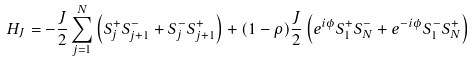<formula> <loc_0><loc_0><loc_500><loc_500>H _ { J } = - \frac { J } { 2 } \sum _ { j = 1 } ^ { N } \left ( S _ { j } ^ { + } S _ { j + 1 } ^ { - } + S _ { j } ^ { - } S _ { j + 1 } ^ { + } \right ) + ( 1 - \rho ) \frac { J } { 2 } \left ( e ^ { i \phi } S _ { 1 } ^ { + } S _ { N } ^ { - } + e ^ { - i \phi } S _ { 1 } ^ { - } S _ { N } ^ { + } \right )</formula> 